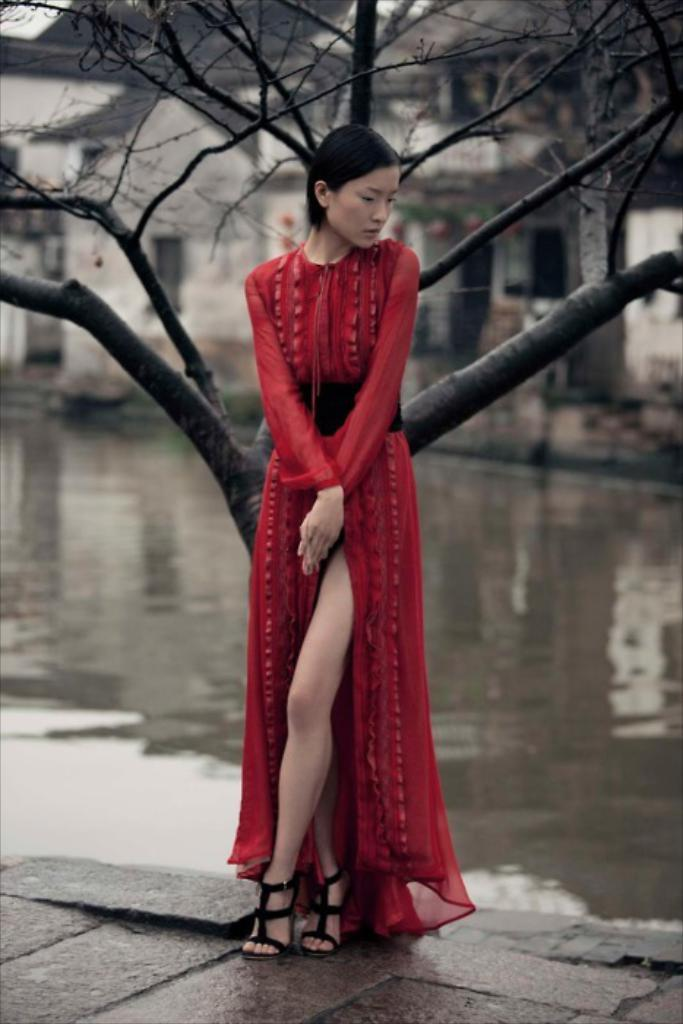Who is the main subject in the image? There is a girl in the image. What can be seen behind the girl? There is a tree behind the girl. What is located behind the tree? There is a river behind the tree. What else can be seen in the background of the image? There is a building in the background of the image. What type of quartz can be seen on the girl's shirt in the image? There is no quartz visible on the girl's shirt in the image. Can you describe the insect that is sitting on the girl's shoulder in the image? There is no insect present on the girl's shoulder in the image. 